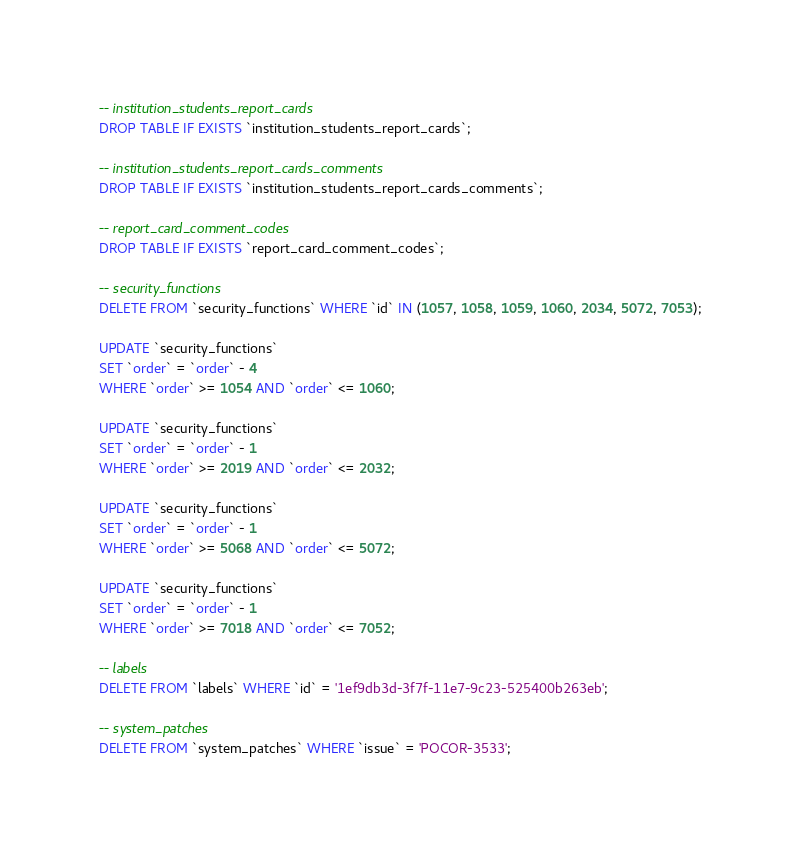<code> <loc_0><loc_0><loc_500><loc_500><_SQL_>
-- institution_students_report_cards
DROP TABLE IF EXISTS `institution_students_report_cards`;

-- institution_students_report_cards_comments
DROP TABLE IF EXISTS `institution_students_report_cards_comments`;

-- report_card_comment_codes
DROP TABLE IF EXISTS `report_card_comment_codes`;

-- security_functions
DELETE FROM `security_functions` WHERE `id` IN (1057, 1058, 1059, 1060, 2034, 5072, 7053);

UPDATE `security_functions`
SET `order` = `order` - 4
WHERE `order` >= 1054 AND `order` <= 1060;

UPDATE `security_functions`
SET `order` = `order` - 1
WHERE `order` >= 2019 AND `order` <= 2032;

UPDATE `security_functions`
SET `order` = `order` - 1
WHERE `order` >= 5068 AND `order` <= 5072;

UPDATE `security_functions`
SET `order` = `order` - 1
WHERE `order` >= 7018 AND `order` <= 7052;

-- labels
DELETE FROM `labels` WHERE `id` = '1ef9db3d-3f7f-11e7-9c23-525400b263eb';

-- system_patches
DELETE FROM `system_patches` WHERE `issue` = 'POCOR-3533';
</code> 